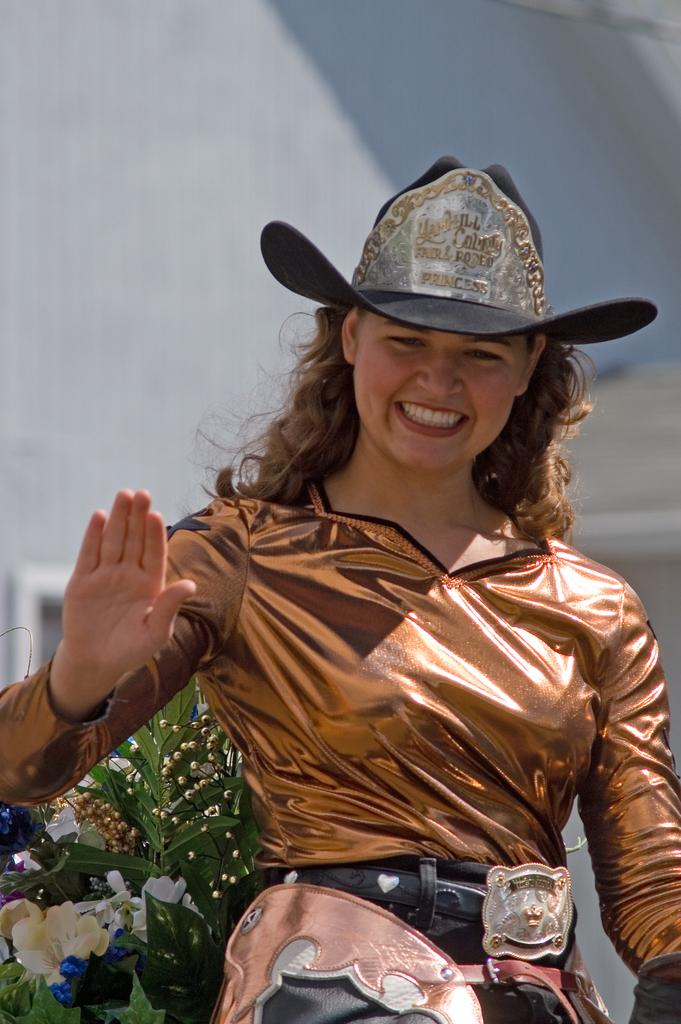Who is present in the image? There is a woman in the image. What is the woman doing in the image? The woman is smiling in the image. What is the woman wearing on her head? The woman is wearing a hat in the image. What type of vegetation can be seen in the image? There are plants with flowers in the image. What can be seen in the background of the image? There is a wall in the background of the image. What type of lock can be seen on the woman's hat in the image? There is no lock present on the woman's hat in the image. What word is written on the wall in the background of the image? There are no words visible on the wall in the background of the image. 